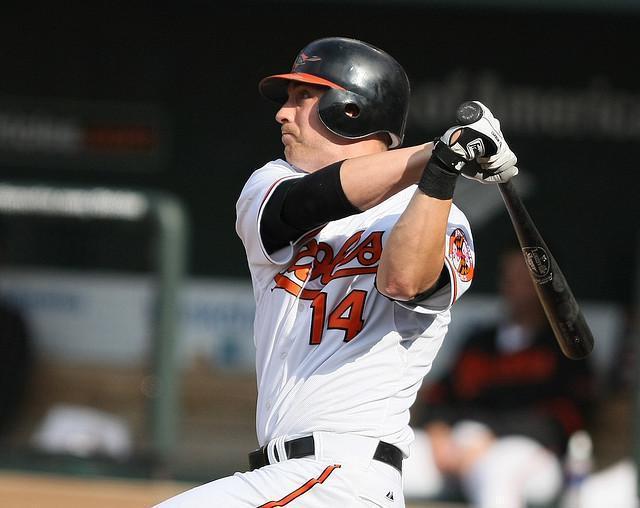How many different types of boats are seen?
Give a very brief answer. 0. 